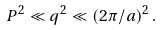Convert formula to latex. <formula><loc_0><loc_0><loc_500><loc_500>P ^ { 2 } \ll q ^ { 2 } \ll ( 2 \pi / a ) ^ { 2 } \, .</formula> 